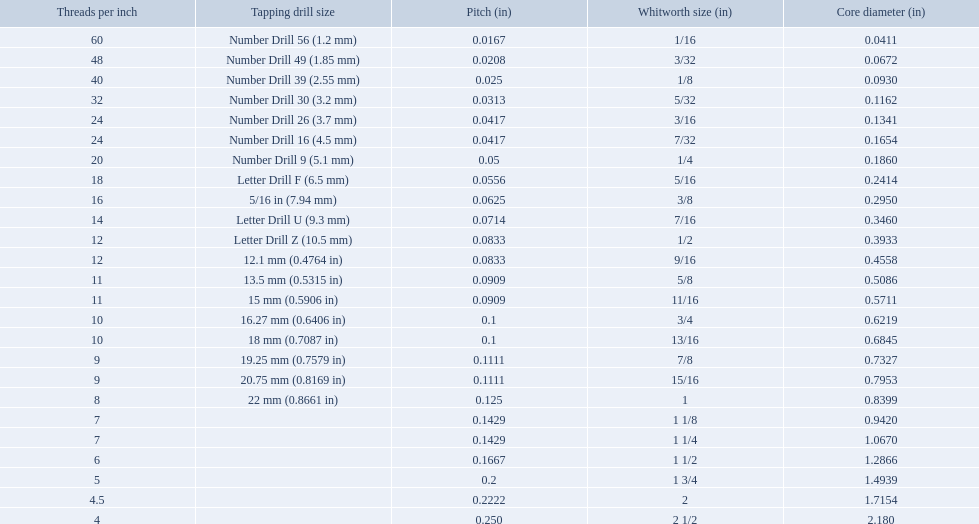Which whitworth size has the same number of threads per inch as 3/16? 7/32. 